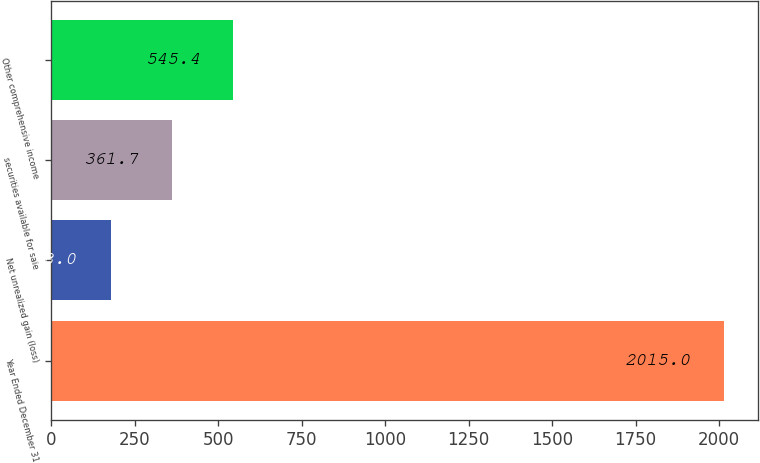<chart> <loc_0><loc_0><loc_500><loc_500><bar_chart><fcel>Year Ended December 31<fcel>Net unrealized gain (loss)<fcel>securities available for sale<fcel>Other comprehensive income<nl><fcel>2015<fcel>178<fcel>361.7<fcel>545.4<nl></chart> 